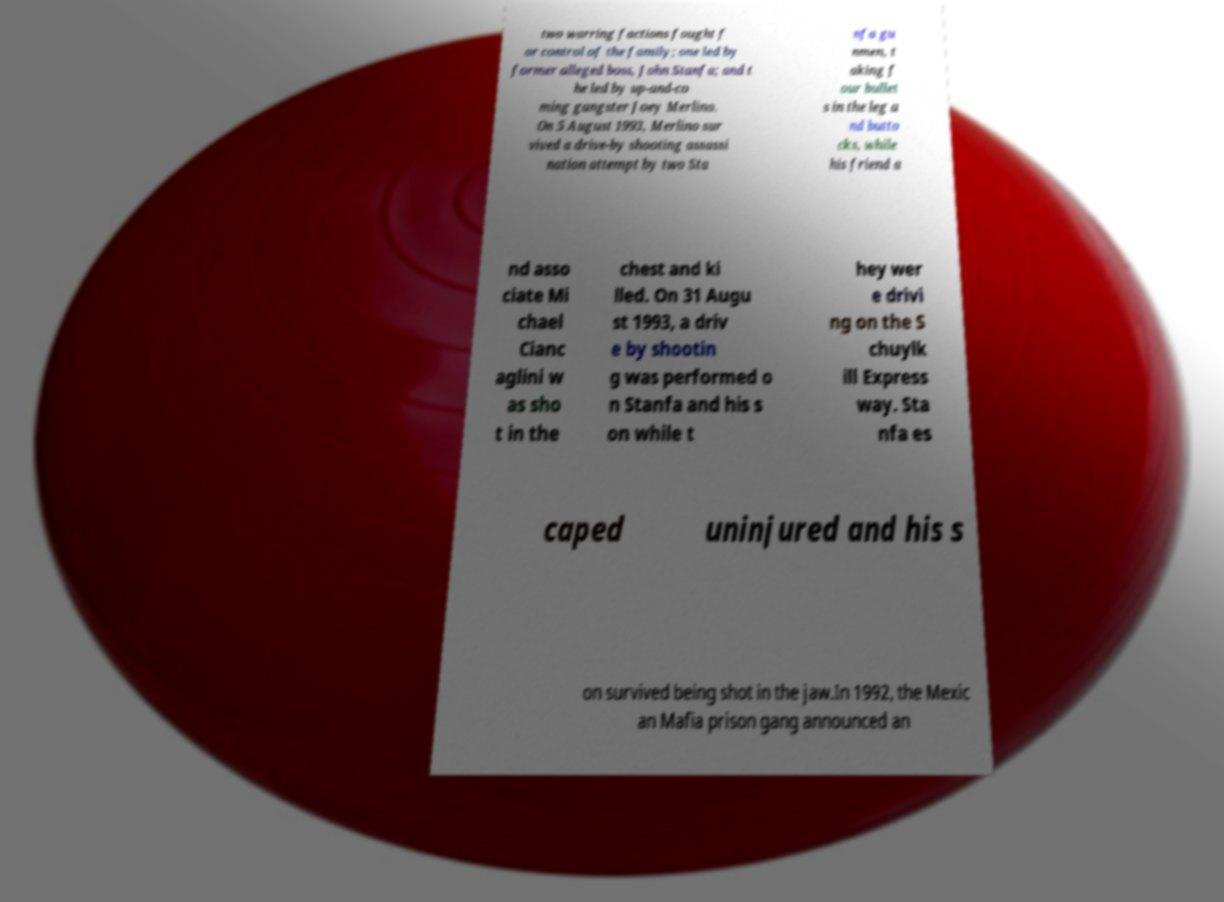For documentation purposes, I need the text within this image transcribed. Could you provide that? two warring factions fought f or control of the family; one led by former alleged boss, John Stanfa; and t he led by up-and-co ming gangster Joey Merlino. On 5 August 1993, Merlino sur vived a drive-by shooting assassi nation attempt by two Sta nfa gu nmen, t aking f our bullet s in the leg a nd butto cks, while his friend a nd asso ciate Mi chael Cianc aglini w as sho t in the chest and ki lled. On 31 Augu st 1993, a driv e by shootin g was performed o n Stanfa and his s on while t hey wer e drivi ng on the S chuylk ill Express way. Sta nfa es caped uninjured and his s on survived being shot in the jaw.In 1992, the Mexic an Mafia prison gang announced an 